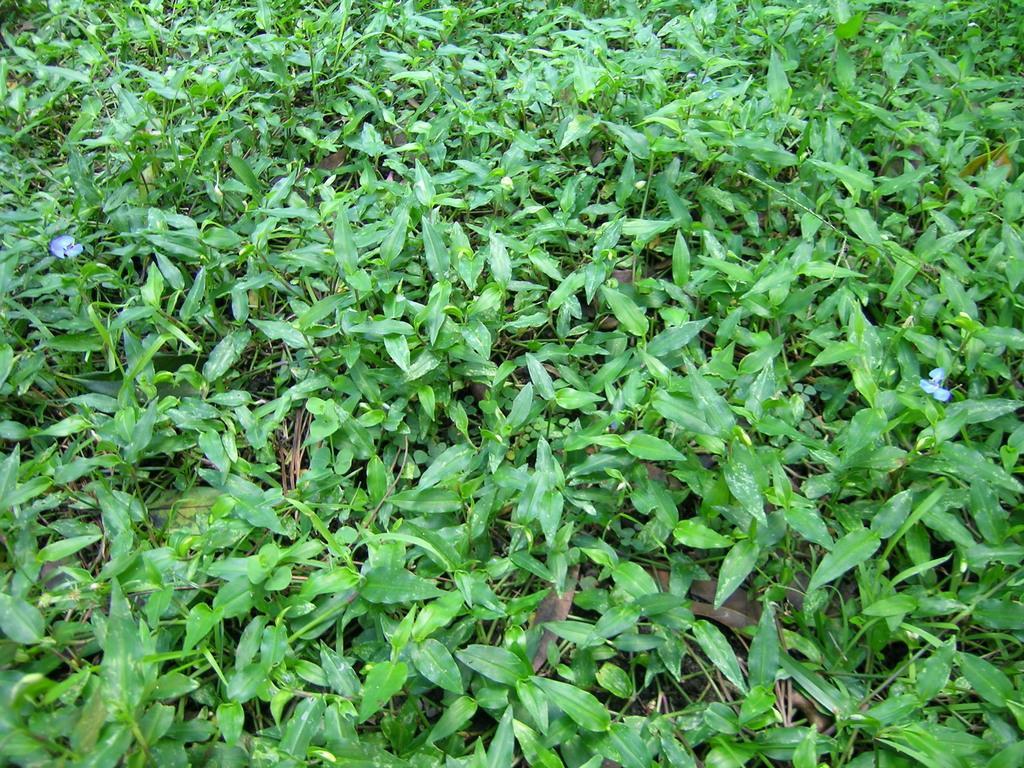Could you give a brief overview of what you see in this image? In this image I can see many plants and there are the purple color flowers can be seen. 